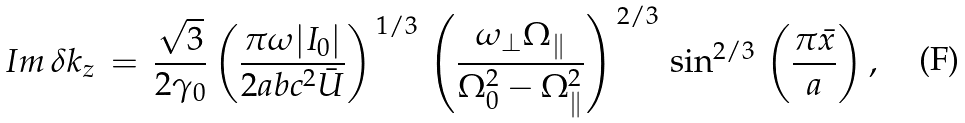Convert formula to latex. <formula><loc_0><loc_0><loc_500><loc_500>I m \, \delta k _ { z } \, = \, \frac { \sqrt { 3 } } { 2 \gamma _ { 0 } } \left ( \frac { \pi \omega | I _ { 0 } | } { 2 a b c ^ { 2 } \bar { U } } \right ) ^ { \, 1 / 3 } \, \left ( \frac { \omega _ { \perp } \Omega _ { \| } } { \Omega _ { 0 } ^ { 2 } - \Omega _ { \| } ^ { 2 } } \right ) ^ { \, 2 / 3 } \, \sin ^ { 2 / 3 } \, \left ( \frac { \pi \bar { x } } { a } \right ) ,</formula> 